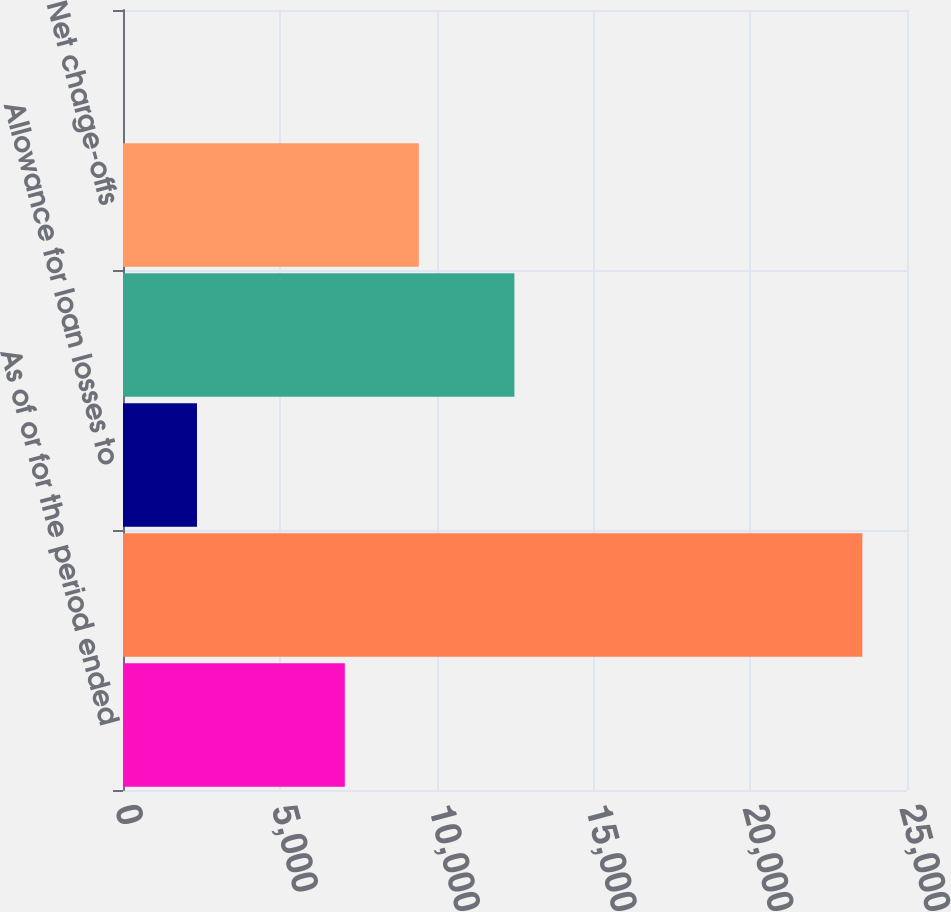Convert chart to OTSL. <chart><loc_0><loc_0><loc_500><loc_500><bar_chart><fcel>As of or for the period ended<fcel>Allowance for credit losses<fcel>Allowance for loan losses to<fcel>Nonperforming assets<fcel>Net charge-offs<fcel>Net charge-off rate<nl><fcel>7073.88<fcel>23576<fcel>2358.98<fcel>12481<fcel>9431.33<fcel>1.53<nl></chart> 